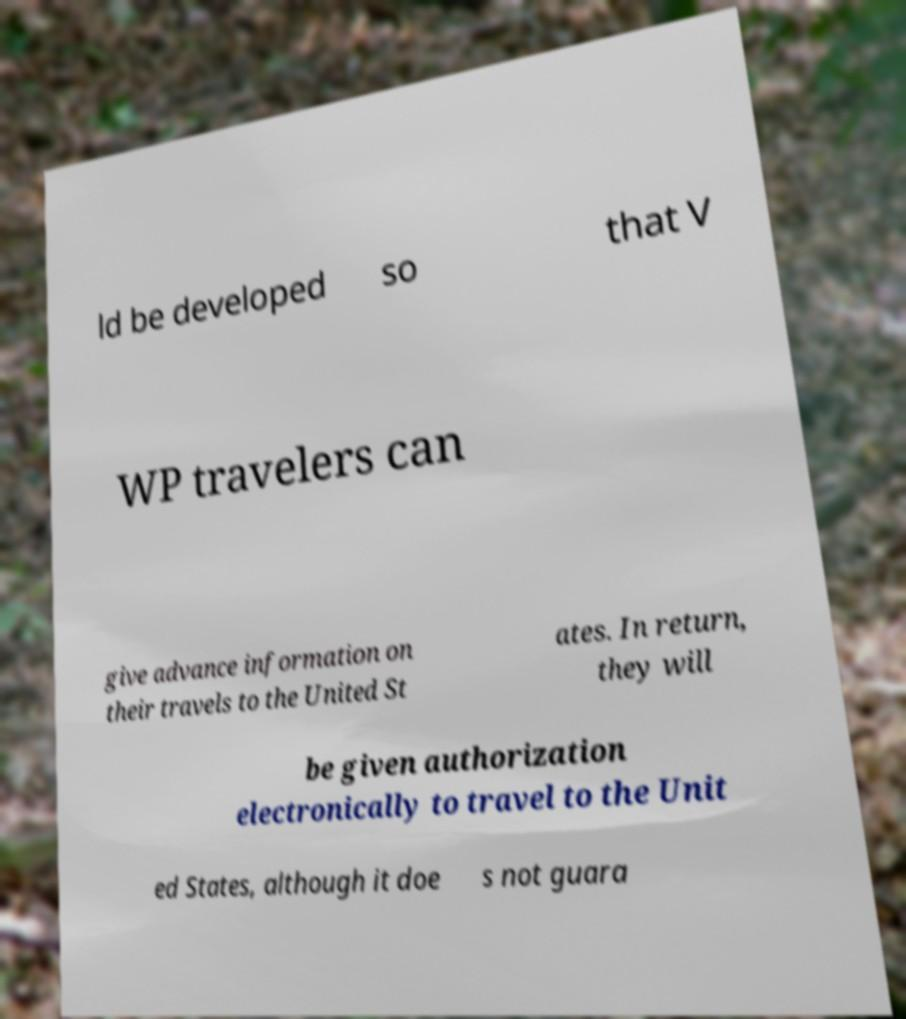There's text embedded in this image that I need extracted. Can you transcribe it verbatim? ld be developed so that V WP travelers can give advance information on their travels to the United St ates. In return, they will be given authorization electronically to travel to the Unit ed States, although it doe s not guara 